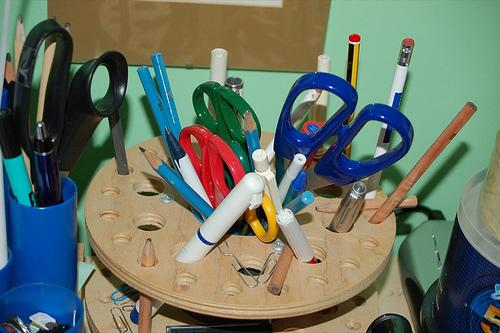What class are these supplies needed for? Please explain your reasoning. art class. These supplies are used for art works. 